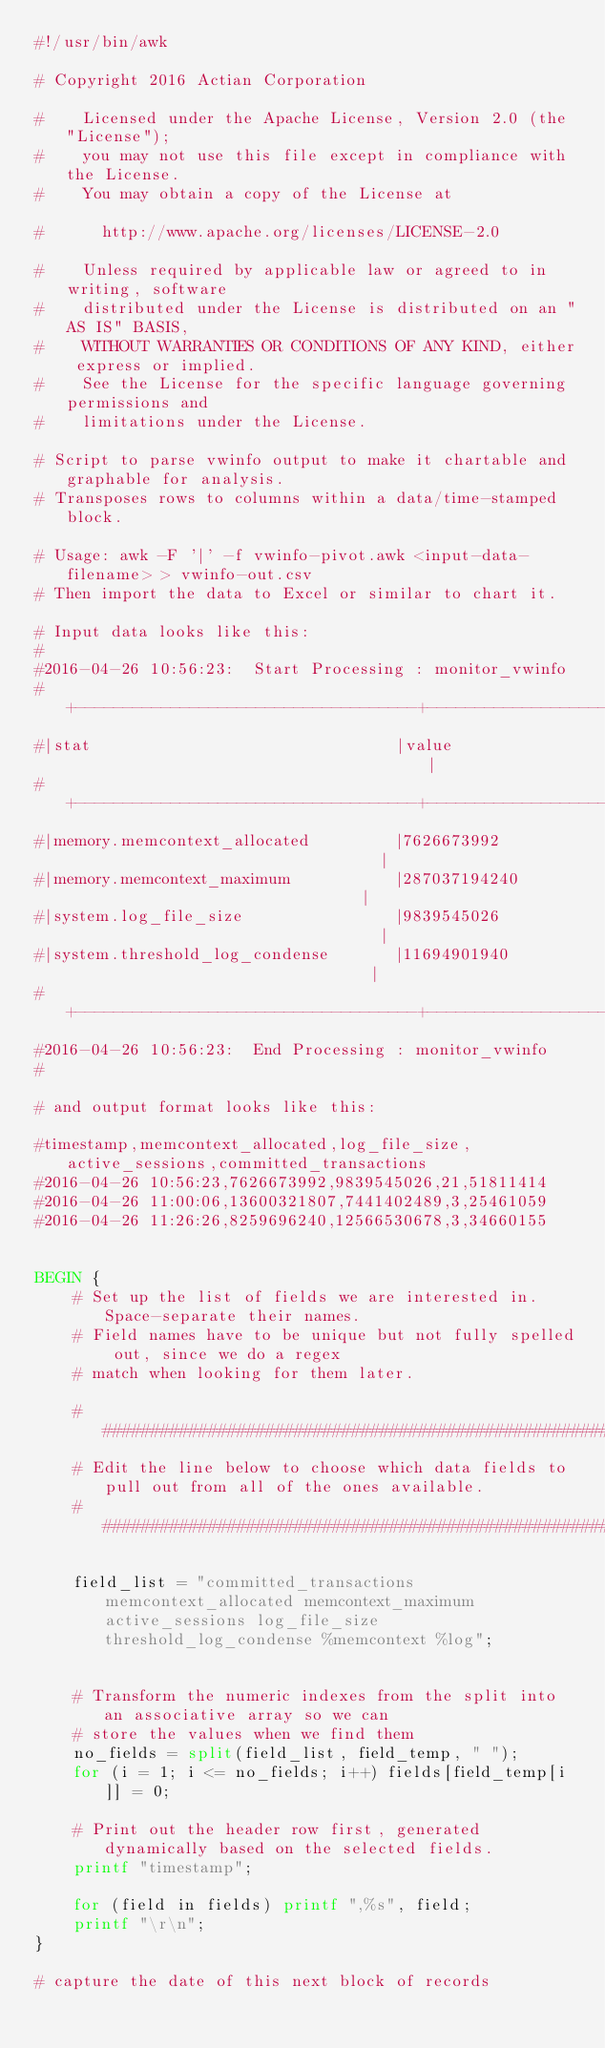Convert code to text. <code><loc_0><loc_0><loc_500><loc_500><_Awk_>#!/usr/bin/awk

# Copyright 2016 Actian Corporation
 
#    Licensed under the Apache License, Version 2.0 (the "License");
#    you may not use this file except in compliance with the License.
#    You may obtain a copy of the License at
 
#      http://www.apache.org/licenses/LICENSE-2.0
 
#    Unless required by applicable law or agreed to in writing, software
#    distributed under the License is distributed on an "AS IS" BASIS,
#    WITHOUT WARRANTIES OR CONDITIONS OF ANY KIND, either express or implied.
#    See the License for the specific language governing permissions and
#    limitations under the License.

# Script to parse vwinfo output to make it chartable and graphable for analysis.
# Transposes rows to columns within a data/time-stamped block.

# Usage: awk -F '|' -f vwinfo-pivot.awk <input-data-filename> > vwinfo-out.csv
# Then import the data to Excel or similar to chart it.

# Input data looks like this:
#
#2016-04-26 10:56:23:  Start Processing : monitor_vwinfo
#+------------------------------------+--------------------------------------------+
#|stat                                |value                                       |
#+------------------------------------+--------------------------------------------+
#|memory.memcontext_allocated         |7626673992                                  |
#|memory.memcontext_maximum           |287037194240                                |
#|system.log_file_size                |9839545026                                  |
#|system.threshold_log_condense       |11694901940                                 |
#+------------------------------------+--------------------------------------------+
#2016-04-26 10:56:23:  End Processing : monitor_vwinfo
#

# and output format looks like this:

#timestamp,memcontext_allocated,log_file_size,active_sessions,committed_transactions
#2016-04-26 10:56:23,7626673992,9839545026,21,51811414
#2016-04-26 11:00:06,13600321807,7441402489,3,25461059
#2016-04-26 11:26:26,8259696240,12566530678,3,34660155


BEGIN {
	# Set up the list of fields we are interested in. Space-separate their names.
	# Field names have to be unique but not fully spelled out, since we do a regex
	# match when looking for them later.

	###################################################################
	# Edit the line below to choose which data fields to pull out from all of the ones available. 
	###################################################################

	field_list = "committed_transactions memcontext_allocated memcontext_maximum active_sessions log_file_size threshold_log_condense %memcontext %log";


	# Transform the numeric indexes from the split into an associative array so we can 
	# store the values when we find them
	no_fields = split(field_list, field_temp, " ");
	for (i = 1; i <= no_fields; i++) fields[field_temp[i]] = 0;

	# Print out the header row first, generated dynamically based on the selected fields.
	printf "timestamp";

	for (field in fields) printf ",%s", field;
	printf "\r\n";
}

# capture the date of this next block of records</code> 